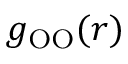<formula> <loc_0><loc_0><loc_500><loc_500>g _ { O O } ( r )</formula> 